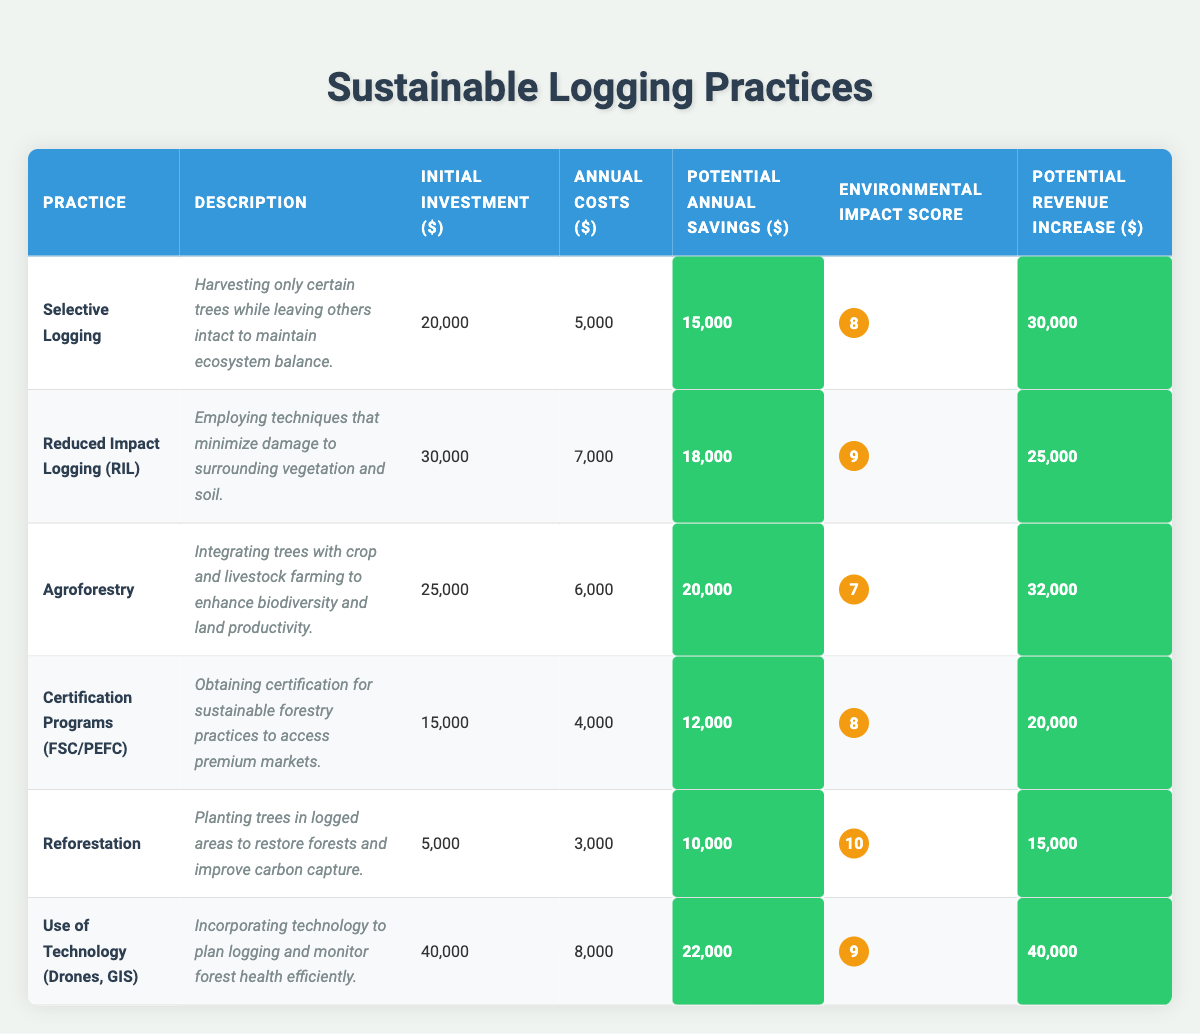What is the potential annual savings for Selective Logging? In the table, for the practice of Selective Logging, the potential annual savings value is provided directly as $15,000.
Answer: $15,000 What is the environmental impact score of Reduced Impact Logging? The environmental impact score for Reduced Impact Logging (RIL) is provided in the table as a numerical value, which is 9.
Answer: 9 Which logging practice has the lowest initial investment? By comparing the initial investment values listed in the table, the practice with the lowest initial investment is Reforestation, which costs $5,000.
Answer: $5,000 What is the total potential revenue increase from Agroforestry and Certification Programs? The potential revenue increase for Agroforestry is $32,000 and for Certification Programs is $20,000. Adding these together gives $32,000 + $20,000 = $52,000.
Answer: $52,000 Is the potential annual savings of Use of Technology greater than that of Reforestation? The potential annual savings for Use of Technology is $22,000, and for Reforestation, it is $10,000. Since $22,000 is greater than $10,000, the answer is yes.
Answer: Yes What is the difference between the potential annual savings of Reduced Impact Logging and Selective Logging? To find the difference, subtract the potential annual savings of Selective Logging ($15,000) from that of Reduced Impact Logging ($18,000): $18,000 - $15,000 = $3,000.
Answer: $3,000 Which logging practice has the highest environmental impact score? By examining the environmental impact scores listed in the table, Reforestation has the highest score of 10.
Answer: 10 What is the average initial investment for all the logging practices listed? Add the initial investments: $20,000 + $30,000 + $25,000 + $15,000 + $5,000 + $40,000 = $135,000. There are 6 practices, so divide: $135,000 / 6 = $22,500.
Answer: $22,500 What is the annual cost of the practice with the highest potential revenue increase? The practice with the highest potential revenue increase is Use of Technology, which has an annual cost of $8,000 as noted in the table.
Answer: $8,000 Which sustainable logging practice offers the highest potential annual savings? Reviewing the table, the practice with the highest potential annual savings is Use of Technology, with savings of $22,000.
Answer: Use of Technology If I implement Agroforestry, what will be my net savings after covering the initial investment and annual costs for the first year? The initial investment is $25,000 and the annual costs are $6,000; the potential annual savings is $20,000. First-year net savings: $20,000 - ($25,000 + $6,000) = $20,000 - $31,000 = -$11,000. Therefore, the net savings would be negative, indicating a loss.
Answer: -$11,000 